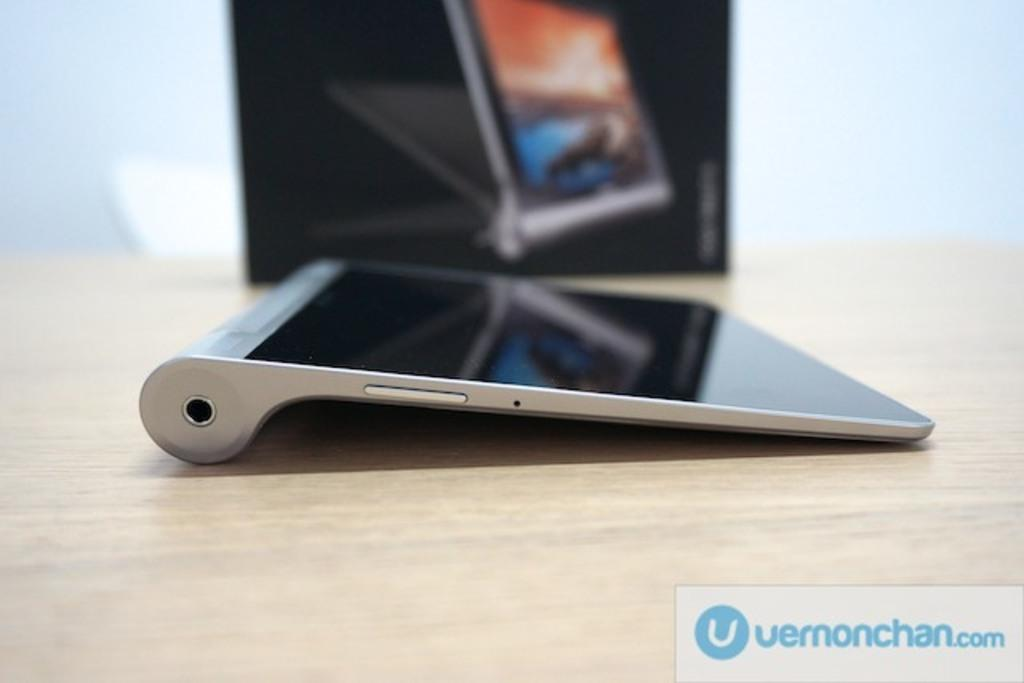<image>
Summarize the visual content of the image. An electronic device is on a wooden table and is sold by vernonchan.com 